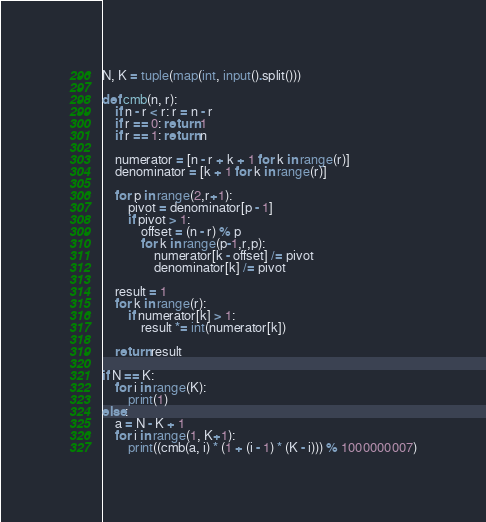Convert code to text. <code><loc_0><loc_0><loc_500><loc_500><_Python_>N, K = tuple(map(int, input().split()))

def cmb(n, r):
    if n - r < r: r = n - r
    if r == 0: return 1
    if r == 1: return n

    numerator = [n - r + k + 1 for k in range(r)]
    denominator = [k + 1 for k in range(r)]

    for p in range(2,r+1):
        pivot = denominator[p - 1]
        if pivot > 1:
            offset = (n - r) % p
            for k in range(p-1,r,p):
                numerator[k - offset] /= pivot
                denominator[k] /= pivot

    result = 1
    for k in range(r):
        if numerator[k] > 1:
            result *= int(numerator[k])

    return result

if N == K:
    for i in range(K):
        print(1)
else:
    a = N - K + 1
    for i in range(1, K+1):
        print((cmb(a, i) * (1 + (i - 1) * (K - i))) % 1000000007)
</code> 